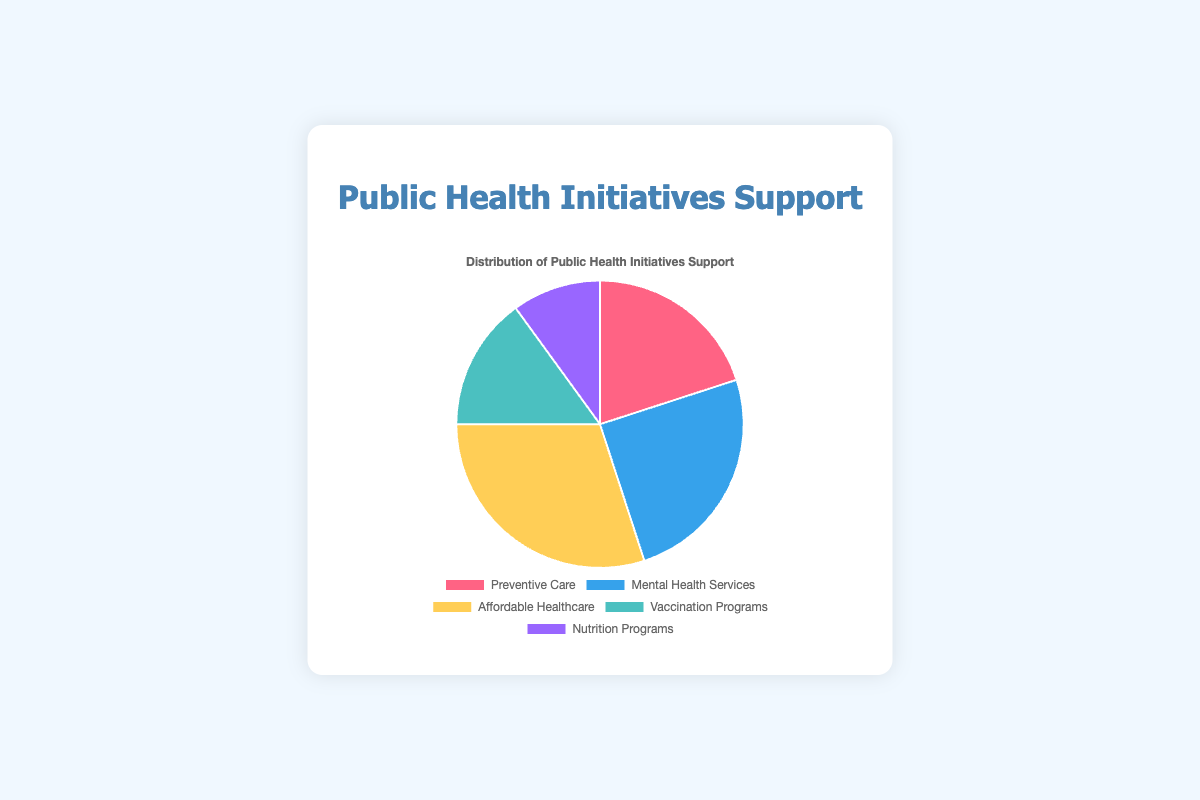Which initiative has the highest support? Among the segments in the pie chart, the segment for Affordable Healthcare is the largest. This indicates that Affordable Healthcare has the highest support.
Answer: Affordable Healthcare Which initiative has the smallest support? The segment for Nutrition Programs in the pie chart is the smallest, indicating it has the smallest support.
Answer: Nutrition Programs What is the combined support for Preventive Care and Mental Health Services? Add the support percentages of Preventive Care (20%) and Mental Health Services (25%): 20 + 25 = 45%.
Answer: 45% Is the support for Vaccination Programs greater than the support for Nutrition Programs? The pie chart shows that the Vaccination Programs segment is larger than the Nutrition Programs segment, with 15% and 10% support respectively.
Answer: Yes How much larger is the support for Affordable Healthcare compared to Preventive Care? Subtract the support percentage of Preventive Care (20%) from Affordable Healthcare (30%): 30 - 20 = 10%.
Answer: 10% Which initiatives together make up more than 50% of the support? Adding Affordable Healthcare (30%) and Mental Health Services (25%) gives 55%, which is more than 50%.
Answer: Affordable Healthcare and Mental Health Services What is the difference in support between the highest and lowest supported initiatives? Subtract the support percentage of Nutrition Programs (10%) from Affordable Healthcare (30%): 30 - 10 = 20%.
Answer: 20% What is the average support for all initiatives? Sum the percentages: 20 + 25 + 30 + 15 + 10 = 100. Divide by 5 to get the average: 100 / 5 = 20%.
Answer: 20% 